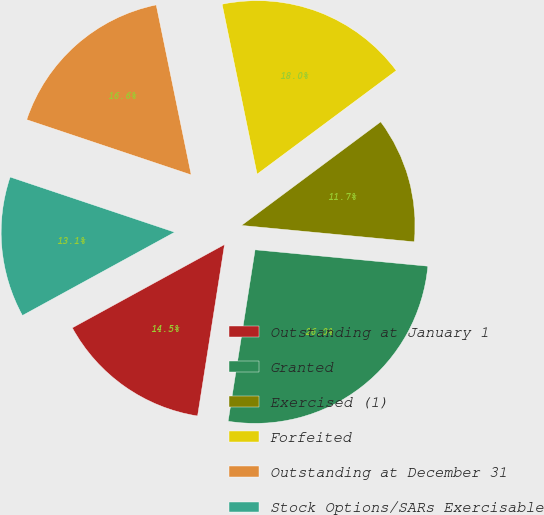Convert chart to OTSL. <chart><loc_0><loc_0><loc_500><loc_500><pie_chart><fcel>Outstanding at January 1<fcel>Granted<fcel>Exercised (1)<fcel>Forfeited<fcel>Outstanding at December 31<fcel>Stock Options/SARs Exercisable<nl><fcel>14.55%<fcel>25.98%<fcel>11.69%<fcel>18.05%<fcel>16.62%<fcel>13.12%<nl></chart> 